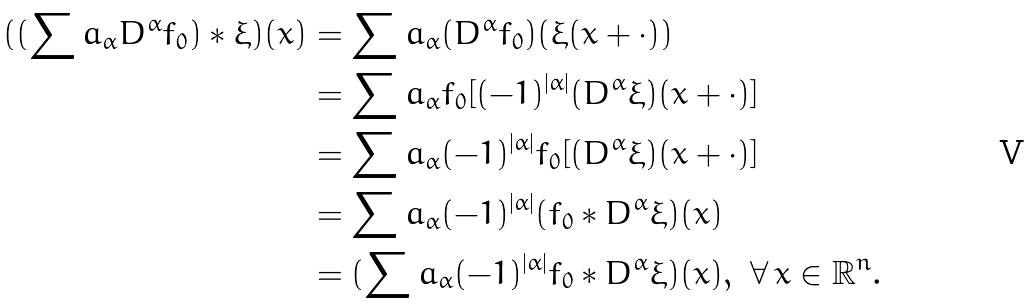Convert formula to latex. <formula><loc_0><loc_0><loc_500><loc_500>( ( \sum a _ { \alpha } D ^ { \alpha } f _ { 0 } ) \ast \xi ) ( x ) & = \sum a _ { \alpha } ( D ^ { \alpha } f _ { 0 } ) ( \xi ( x + \cdot ) ) \\ & = \sum a _ { \alpha } f _ { 0 } [ ( - 1 ) ^ { | \alpha | } ( D ^ { \alpha } \xi ) ( x + \cdot ) ] \\ & = \sum a _ { \alpha } ( - 1 ) ^ { | \alpha | } f _ { 0 } [ ( D ^ { \alpha } \xi ) ( x + \cdot ) ] \\ & = \sum a _ { \alpha } ( - 1 ) ^ { | \alpha | } ( f _ { 0 } \ast D ^ { \alpha } \xi ) ( x ) \\ & = ( \sum a _ { \alpha } ( - 1 ) ^ { | \alpha | } f _ { 0 } \ast D ^ { \alpha } \xi ) ( x ) , \ \forall \, x \in \mathbb { R } ^ { n } .</formula> 